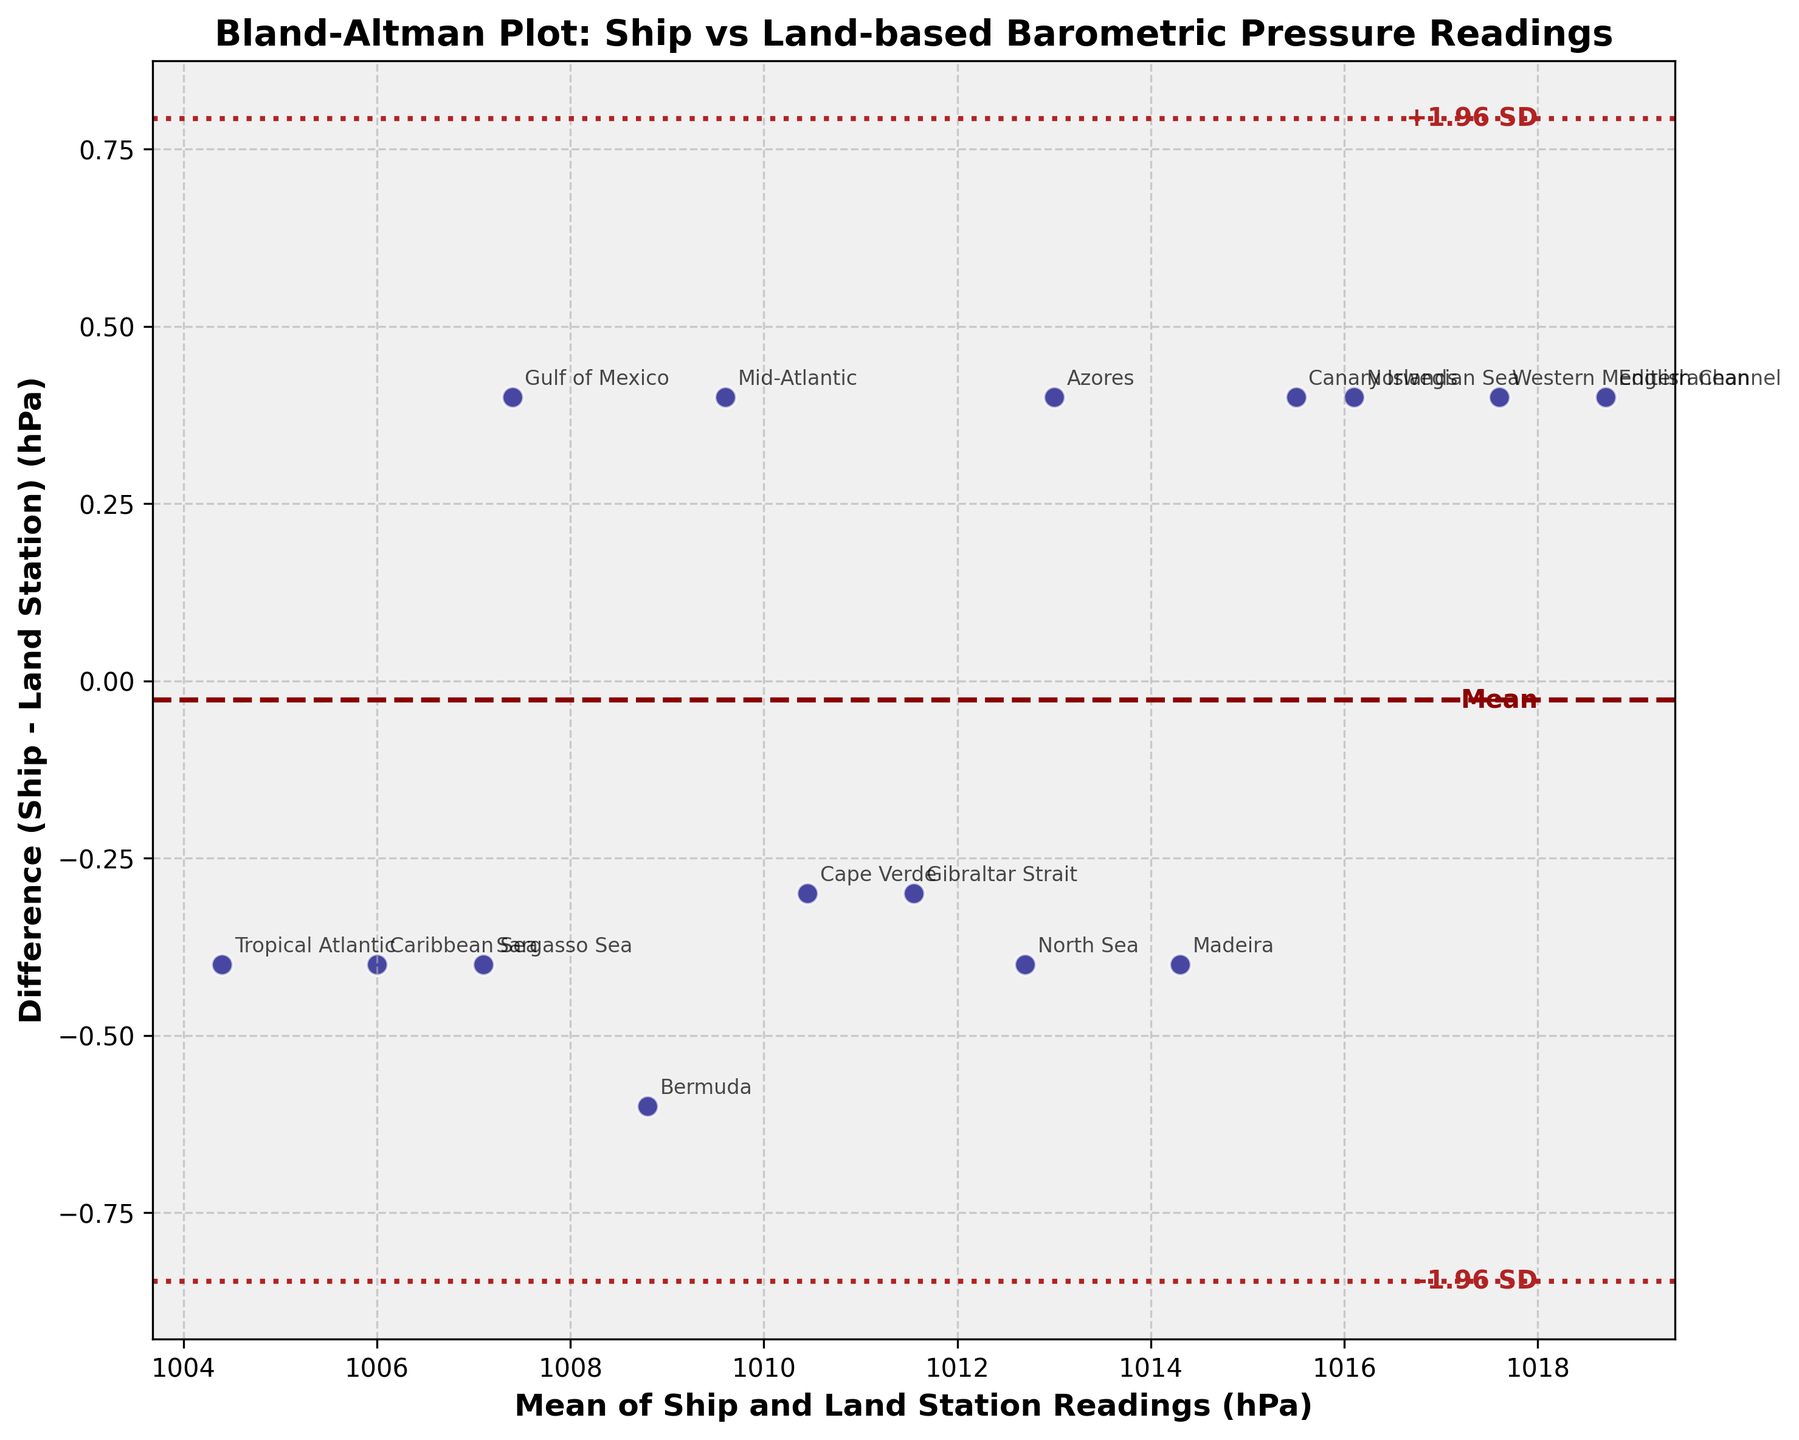What is the title of the plot? The title of the plot is displayed at the top center, indicating the content and purpose of the visual.
Answer: Bland-Altman Plot: Ship vs Land-based Barometric Pressure Readings Which axis represents the mean of Ship and Land Station readings? The x-axis represents the mean values, as indicated by the label "Mean of Ship and Land Station Readings (hPa)".
Answer: x-axis How many horizontal lines are present in the plot? There are three horizontal lines across the plot which can be identified visually: one solid line and two dashed lines.
Answer: 3 What do the dashed lines on the plot represent? The dashed lines represent the limits of agreement, which are calculated as the mean difference plus and minus 1.96 times the standard deviation of the differences.
Answer: Limits of agreement What is the approximate difference in readings for Madeira? The data point labeled 'Madeira' is slightly above zero on the y-axis, indicating a small positive difference.
Answer: ~ -0.4 What are the mean readings and difference for the location with the highest mean reading? The location with the highest mean reading is Western Mediterranean, with coordinates on the x-axis around 1017.6 hPa and a negative difference on the y-axis.
Answer: Western Mediterranean: Mean ≈ 1017.6 hPa, Difference ≈ -0.4 hPa Is there a location where the ship reading is higher than the land station reading? By observing the points on the plot, data points above the zero difference line indicate that the ship readings are higher than the land station readings.
Answer: Yes Which location has the lowest mean pressure reading? The Sargasso Sea has the lowest point on the x-axis representing the lowest mean pressure reading.
Answer: Sargasso Sea What is the range of mean pressure readings depicted on the x-axis? By looking at the x-axis from the leftmost to the rightmost data points, the range of mean pressure readings can be determined.
Answer: ~1004.4 to ~1017.6 hPa How many data points indicate a positive difference between the ship and the land station readings? Positive differences are represented by points above the zero line on the y-axis; count these points to get the answer.
Answer: 5 